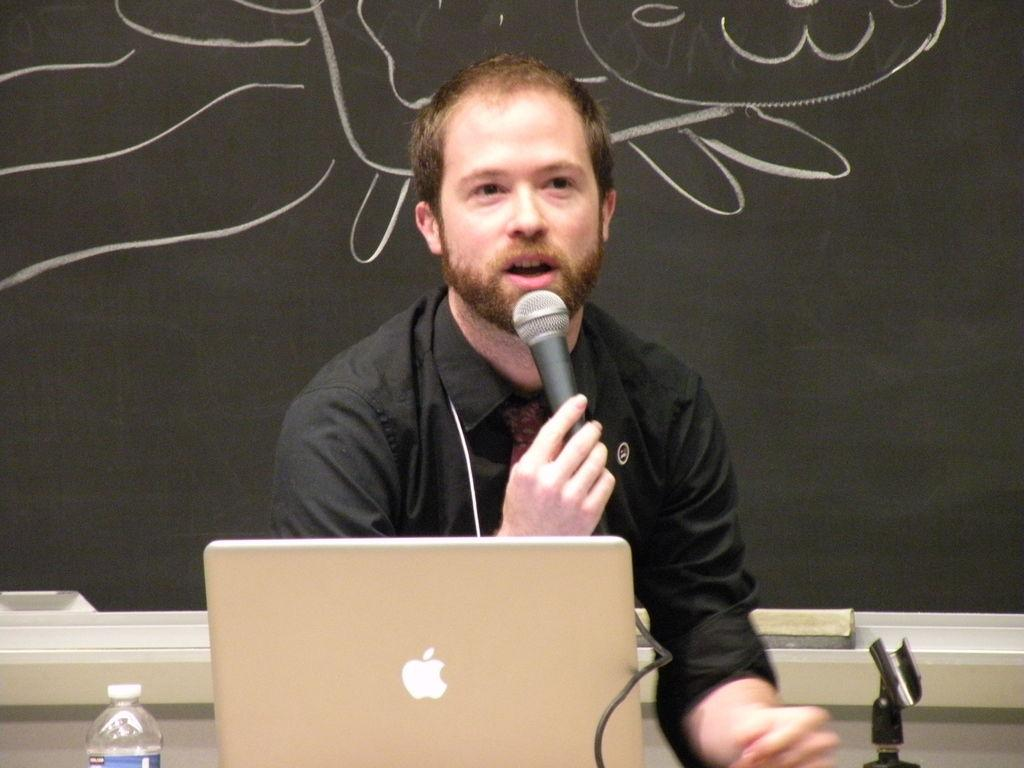What is the person in the image holding? The person is holding a microphone in the image. What electronic device can be seen in the image? There is a laptop visible in the image. What type of container is present in the image? There is a bottle in the image. What color is the board in the background of the image? The board in the background of the image is black-colored. What type of fowl is present in the image? There is no fowl present in the image. 